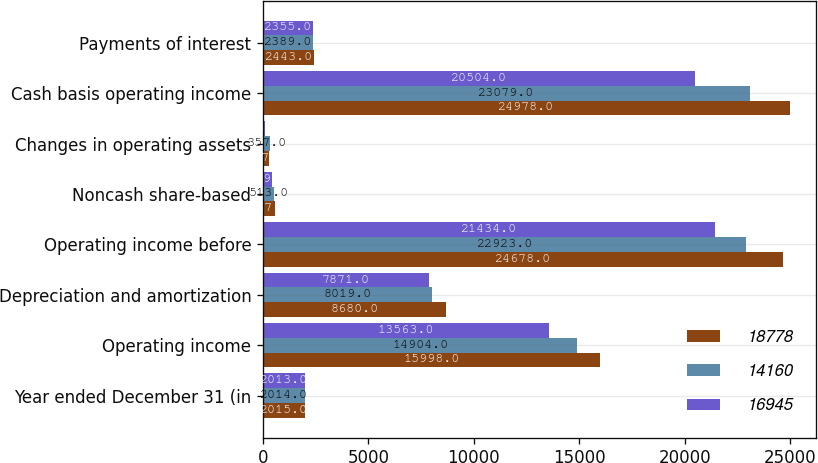<chart> <loc_0><loc_0><loc_500><loc_500><stacked_bar_chart><ecel><fcel>Year ended December 31 (in<fcel>Operating income<fcel>Depreciation and amortization<fcel>Operating income before<fcel>Noncash share-based<fcel>Changes in operating assets<fcel>Cash basis operating income<fcel>Payments of interest<nl><fcel>18778<fcel>2015<fcel>15998<fcel>8680<fcel>24678<fcel>567<fcel>267<fcel>24978<fcel>2443<nl><fcel>14160<fcel>2014<fcel>14904<fcel>8019<fcel>22923<fcel>513<fcel>357<fcel>23079<fcel>2389<nl><fcel>16945<fcel>2013<fcel>13563<fcel>7871<fcel>21434<fcel>419<fcel>93<fcel>20504<fcel>2355<nl></chart> 